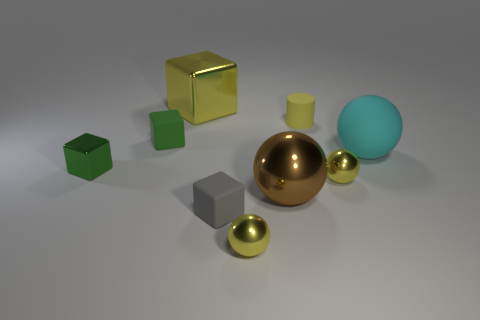What is the texture of the tiny green cube? The tiny green cube has a matte, non-reflective texture, contrasting with the other objects in the scene that have reflective surfaces, indicating it might be made of a plastic material with a flat or satin finish. 